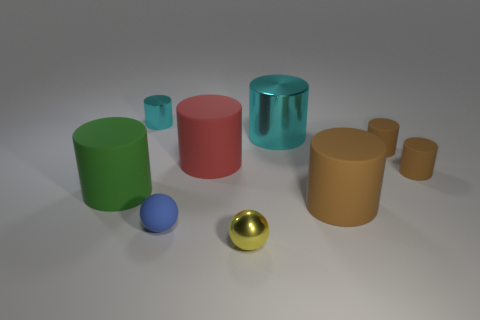Is the number of cyan shiny cylinders that are to the right of the small yellow ball greater than the number of large brown objects that are left of the red cylinder?
Keep it short and to the point. Yes. What number of metallic objects are big brown cylinders or purple cylinders?
Provide a short and direct response. 0. What is the shape of the tiny shiny thing that is the same color as the big metallic cylinder?
Give a very brief answer. Cylinder. There is a object that is left of the tiny cyan thing; what is its material?
Ensure brevity in your answer.  Rubber. What number of things are either small gray balls or brown cylinders behind the big brown matte cylinder?
Your response must be concise. 2. There is a metal object that is the same size as the red rubber cylinder; what is its shape?
Make the answer very short. Cylinder. What number of large matte objects are the same color as the big metallic thing?
Make the answer very short. 0. Is the material of the red cylinder that is behind the small metal ball the same as the large cyan cylinder?
Your answer should be very brief. No. There is a tiny blue rubber object; what shape is it?
Provide a succinct answer. Sphere. What number of purple things are either big rubber cylinders or large things?
Offer a terse response. 0. 